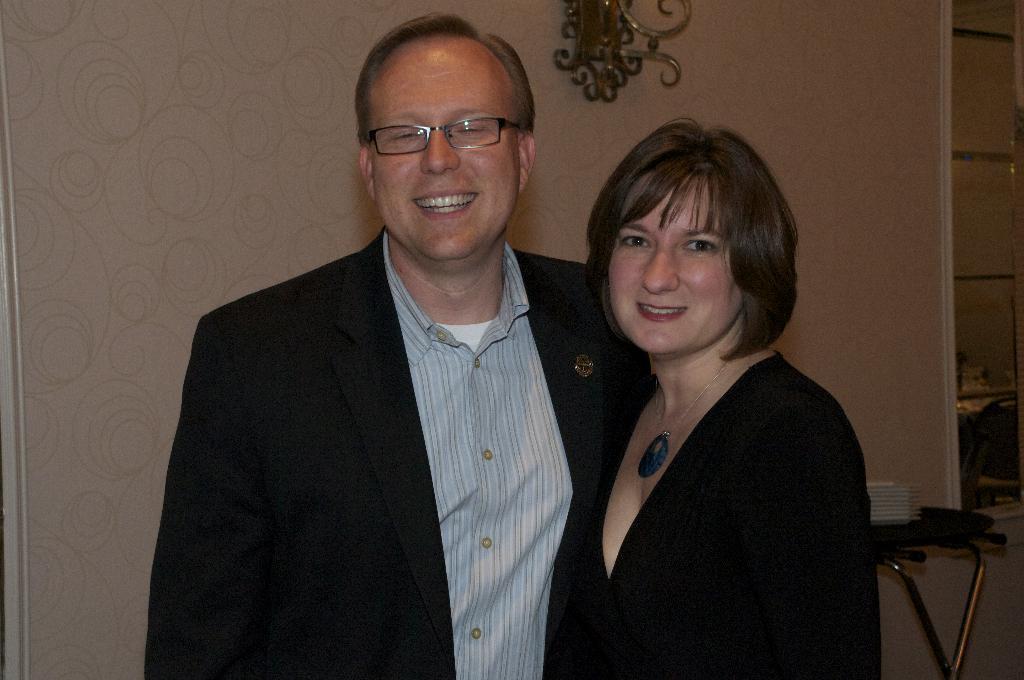Can you describe this image briefly? In the middle of the image two persons are standing and smiling. Behind them we can see a wall and table, on the table we can see some plates. 